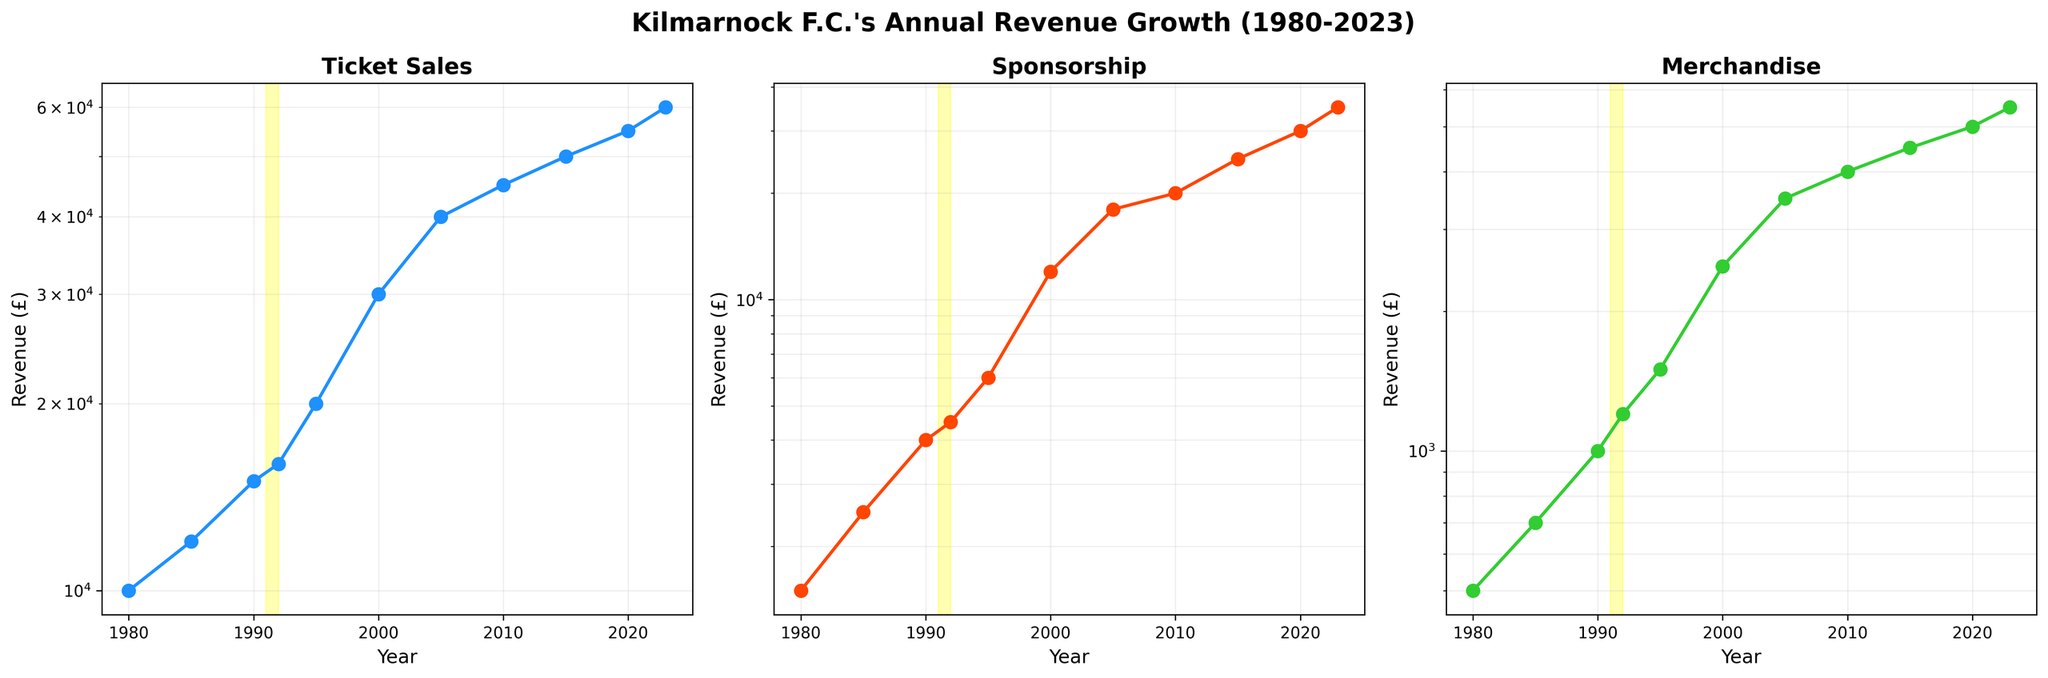What's the title of the plot? The plot's title is displayed at the top and reads "Kilmarnock F.C.'s Annual Revenue Growth (1980-2023)".
Answer: Kilmarnock F.C.'s Annual Revenue Growth (1980-2023) Which category had the highest revenue in 2023? By examining the endpoints of the three lines and reading the values on the y-axis, the category with the highest revenue in 2023 is "Ticket Sales", reaching £60,000.
Answer: Ticket Sales What is the difference in Merchandise revenue between 1995 and 2020? Identify the Merchandise revenue values for 1995 (£1,500) and 2020 (£5,000) from the log scale on the axis, then subtract the former from the latter: £5,000 - £1,500.
Answer: £3,500 How does the Sponsorship revenue change from 1992 to 2000? Reference the Sponsorship values for 1992 (£4,500) and 2000 (£12,000) and observe the increase. Calculate the difference: £12,000 - £4,500.
Answer: £7,500 In which year did Ticket Sales show a notable increase, and what were the values before and after this increase? Notice the significant change between 1995 and 2000 in Ticket Sales, where the revenue jumped from £20,000 to £30,000.
Answer: 1995 to 2000, £20,000 to £30,000 Which revenue category has the smallest increase from 1980 to 2023? Compare the values for each category in 1980 and 2023. Ticket Sales increased from £10,000 to £60,000, Sponsorship from £1,500 to £35,000, and Merchandise from £500 to £5,500. Merchandise had the smallest increase.
Answer: Merchandise What were the Sponsorship revenues during the '91-'92 season? Look at the highlighted yellow band covering the '91-'92 season on the Sponsorship plot, indicating a revenue of £4,500 each year.
Answer: £4,500 each year By how much did Ticket Sales revenue increase between 1980 and 2010? Locate the values on the y-axis for Ticket Sales in 1980 (£10,000) and 2010 (£45,000). Subtract the 1980 value from the 2010 value: £45,000 - £10,000.
Answer: £35,000 